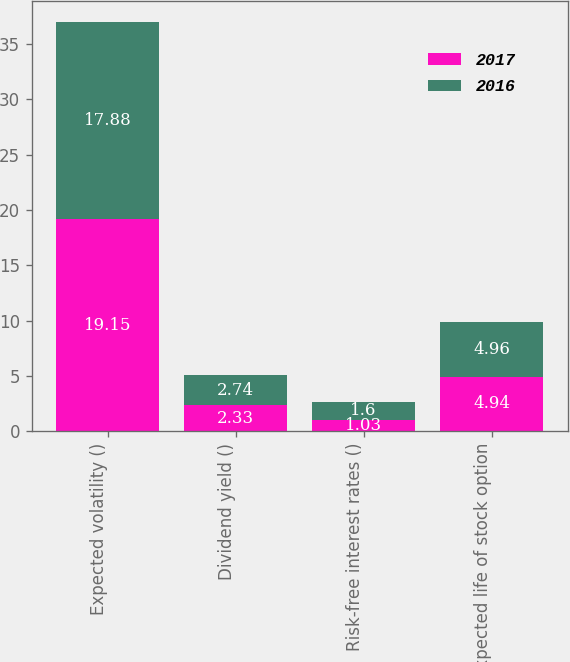<chart> <loc_0><loc_0><loc_500><loc_500><stacked_bar_chart><ecel><fcel>Expected volatility ()<fcel>Dividend yield ()<fcel>Risk-free interest rates ()<fcel>Expected life of stock option<nl><fcel>2017<fcel>19.15<fcel>2.33<fcel>1.03<fcel>4.94<nl><fcel>2016<fcel>17.88<fcel>2.74<fcel>1.6<fcel>4.96<nl></chart> 